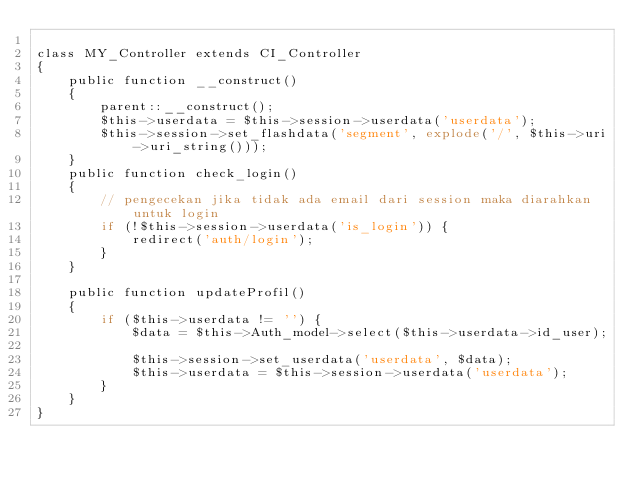<code> <loc_0><loc_0><loc_500><loc_500><_PHP_>
class MY_Controller extends CI_Controller
{
    public function __construct()
    {
        parent::__construct();
        $this->userdata = $this->session->userdata('userdata');
        $this->session->set_flashdata('segment', explode('/', $this->uri->uri_string()));
    }
    public function check_login()
    {
        // pengecekan jika tidak ada email dari session maka diarahkan untuk login
        if (!$this->session->userdata('is_login')) {
            redirect('auth/login');
        }
    }

    public function updateProfil()
    {
        if ($this->userdata != '') {
            $data = $this->Auth_model->select($this->userdata->id_user);

            $this->session->set_userdata('userdata', $data);
            $this->userdata = $this->session->userdata('userdata');
        }
    }
}
</code> 